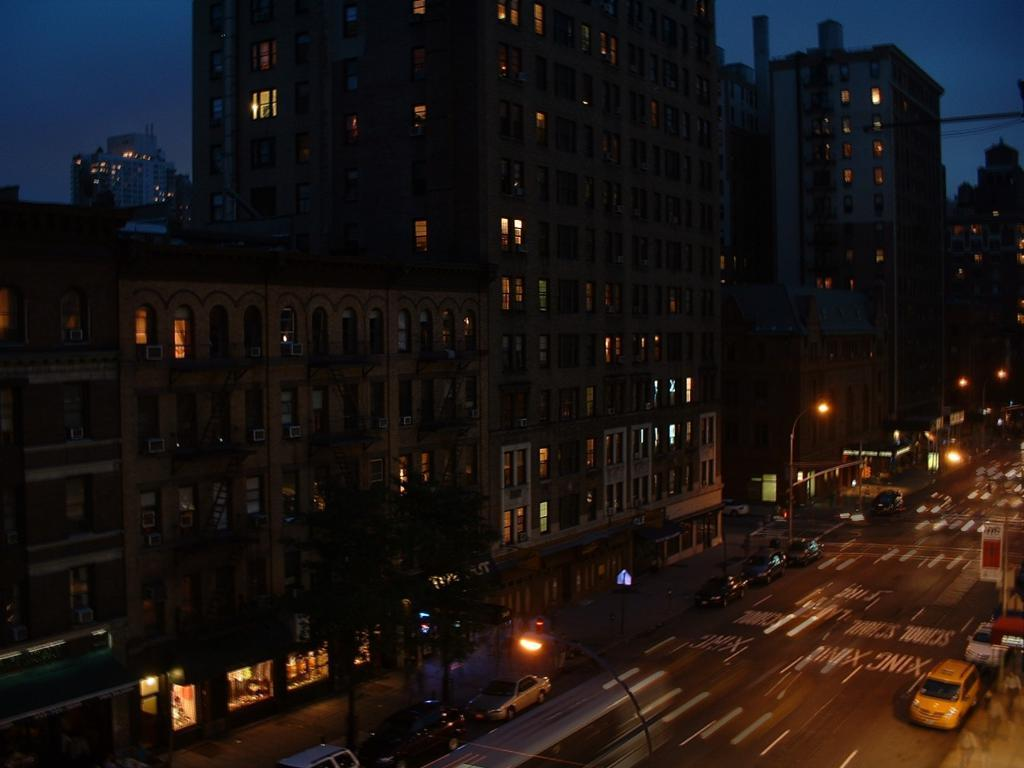What type of structures can be seen in the image? There are buildings in the image. What feature of the buildings is visible in the image? Windows are visible in the image. What appliances are present on the buildings in the image? Air conditioners are present in the image. What type of street furniture can be seen in the image? Street light poles are in the image. What type of signage is visible in the image? Sign boards are visible in the image. What type of transportation is present in the image? Vehicles are on the road in the image. What type of natural elements are present in the image? Trees are present in the image. What part of the natural environment is visible in the image? The sky is visible in the image. What type of juice can be seen being served in the image? There is no juice present in the image. What type of wilderness can be seen in the image? The image does not depict a wilderness setting; it features urban elements such as buildings, vehicles, and street lights. 